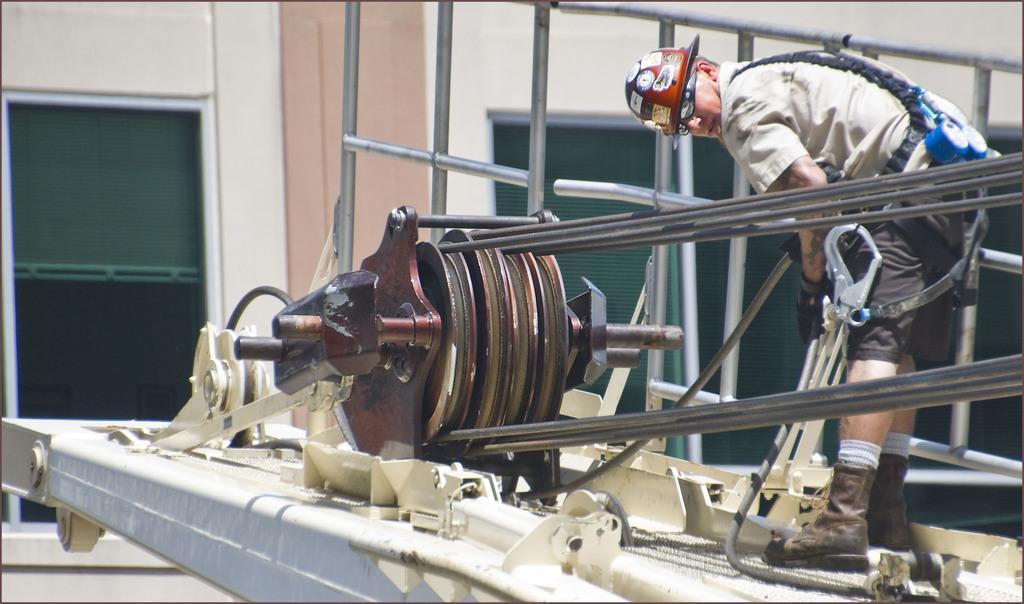Describe this image in one or two sentences. In this image I can see a person is standing and holding few objects in his hands. I can see few wires, few metal rods and few other objects. In the background I can see a building which is cream and brown in color. 